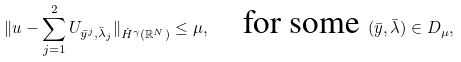Convert formula to latex. <formula><loc_0><loc_0><loc_500><loc_500>\| u - \sum _ { j = 1 } ^ { 2 } U _ { \bar { y } ^ { j } , \bar { \lambda } _ { j } } \| _ { \dot { H } ^ { \gamma } ( \mathbb { R } ^ { N } ) } \leq \mu , \quad \text {for some } ( \bar { y } , \bar { \lambda } ) \in D _ { \mu } ,</formula> 